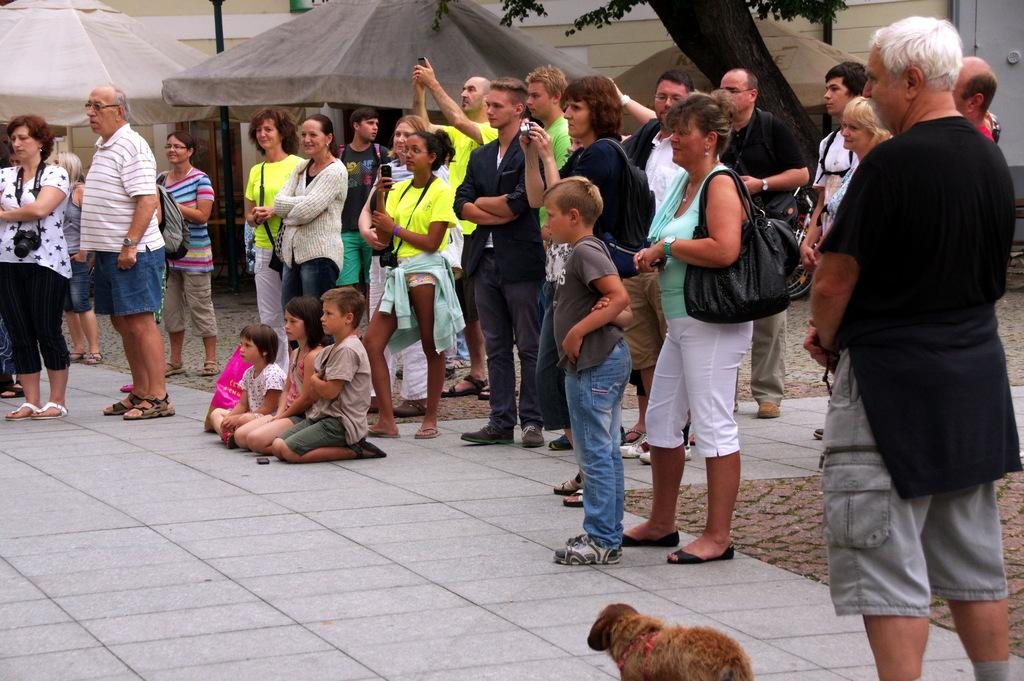What are the persons in the image doing? The persons in the image are on the floor. What animal is present at the bottom of the image? There is a dog at the bottom of the image. What structures can be seen in the background of the image? There are tents, a pole, a building, and a tree in the background of the image. What type of trousers are the brothers wearing in the image? There is no mention of brothers in the image, and no information about trousers is provided. 